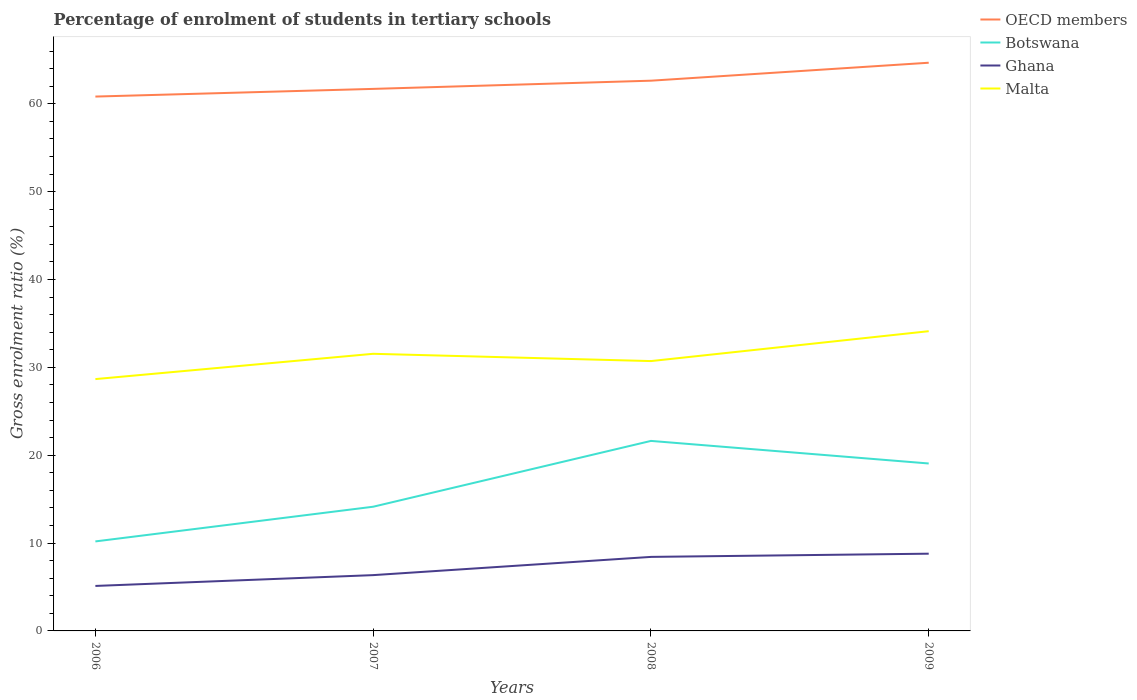Is the number of lines equal to the number of legend labels?
Offer a very short reply. Yes. Across all years, what is the maximum percentage of students enrolled in tertiary schools in Botswana?
Your response must be concise. 10.19. In which year was the percentage of students enrolled in tertiary schools in OECD members maximum?
Provide a succinct answer. 2006. What is the total percentage of students enrolled in tertiary schools in Malta in the graph?
Your answer should be compact. 0.83. What is the difference between the highest and the second highest percentage of students enrolled in tertiary schools in Malta?
Your answer should be compact. 5.45. Is the percentage of students enrolled in tertiary schools in Botswana strictly greater than the percentage of students enrolled in tertiary schools in Ghana over the years?
Keep it short and to the point. No. How many lines are there?
Keep it short and to the point. 4. Are the values on the major ticks of Y-axis written in scientific E-notation?
Your response must be concise. No. Does the graph contain any zero values?
Provide a short and direct response. No. Does the graph contain grids?
Offer a terse response. No. How are the legend labels stacked?
Your answer should be very brief. Vertical. What is the title of the graph?
Your answer should be compact. Percentage of enrolment of students in tertiary schools. Does "Uzbekistan" appear as one of the legend labels in the graph?
Make the answer very short. No. What is the label or title of the X-axis?
Provide a short and direct response. Years. What is the Gross enrolment ratio (%) in OECD members in 2006?
Offer a very short reply. 60.82. What is the Gross enrolment ratio (%) of Botswana in 2006?
Offer a terse response. 10.19. What is the Gross enrolment ratio (%) in Ghana in 2006?
Provide a succinct answer. 5.12. What is the Gross enrolment ratio (%) of Malta in 2006?
Your response must be concise. 28.66. What is the Gross enrolment ratio (%) of OECD members in 2007?
Provide a succinct answer. 61.69. What is the Gross enrolment ratio (%) of Botswana in 2007?
Provide a succinct answer. 14.14. What is the Gross enrolment ratio (%) of Ghana in 2007?
Provide a short and direct response. 6.35. What is the Gross enrolment ratio (%) of Malta in 2007?
Make the answer very short. 31.54. What is the Gross enrolment ratio (%) in OECD members in 2008?
Your response must be concise. 62.62. What is the Gross enrolment ratio (%) of Botswana in 2008?
Provide a succinct answer. 21.63. What is the Gross enrolment ratio (%) in Ghana in 2008?
Offer a very short reply. 8.43. What is the Gross enrolment ratio (%) of Malta in 2008?
Provide a succinct answer. 30.71. What is the Gross enrolment ratio (%) of OECD members in 2009?
Make the answer very short. 64.67. What is the Gross enrolment ratio (%) of Botswana in 2009?
Give a very brief answer. 19.06. What is the Gross enrolment ratio (%) of Ghana in 2009?
Provide a succinct answer. 8.79. What is the Gross enrolment ratio (%) of Malta in 2009?
Provide a succinct answer. 34.11. Across all years, what is the maximum Gross enrolment ratio (%) in OECD members?
Your answer should be compact. 64.67. Across all years, what is the maximum Gross enrolment ratio (%) in Botswana?
Give a very brief answer. 21.63. Across all years, what is the maximum Gross enrolment ratio (%) in Ghana?
Your answer should be compact. 8.79. Across all years, what is the maximum Gross enrolment ratio (%) in Malta?
Your answer should be very brief. 34.11. Across all years, what is the minimum Gross enrolment ratio (%) of OECD members?
Keep it short and to the point. 60.82. Across all years, what is the minimum Gross enrolment ratio (%) in Botswana?
Offer a terse response. 10.19. Across all years, what is the minimum Gross enrolment ratio (%) in Ghana?
Give a very brief answer. 5.12. Across all years, what is the minimum Gross enrolment ratio (%) in Malta?
Ensure brevity in your answer.  28.66. What is the total Gross enrolment ratio (%) in OECD members in the graph?
Provide a short and direct response. 249.81. What is the total Gross enrolment ratio (%) of Botswana in the graph?
Your response must be concise. 65.01. What is the total Gross enrolment ratio (%) of Ghana in the graph?
Provide a short and direct response. 28.69. What is the total Gross enrolment ratio (%) of Malta in the graph?
Your answer should be very brief. 125.03. What is the difference between the Gross enrolment ratio (%) in OECD members in 2006 and that in 2007?
Provide a succinct answer. -0.87. What is the difference between the Gross enrolment ratio (%) in Botswana in 2006 and that in 2007?
Make the answer very short. -3.95. What is the difference between the Gross enrolment ratio (%) in Ghana in 2006 and that in 2007?
Your answer should be very brief. -1.23. What is the difference between the Gross enrolment ratio (%) of Malta in 2006 and that in 2007?
Your answer should be very brief. -2.88. What is the difference between the Gross enrolment ratio (%) of OECD members in 2006 and that in 2008?
Your answer should be compact. -1.81. What is the difference between the Gross enrolment ratio (%) of Botswana in 2006 and that in 2008?
Give a very brief answer. -11.44. What is the difference between the Gross enrolment ratio (%) in Ghana in 2006 and that in 2008?
Make the answer very short. -3.3. What is the difference between the Gross enrolment ratio (%) in Malta in 2006 and that in 2008?
Your answer should be compact. -2.05. What is the difference between the Gross enrolment ratio (%) of OECD members in 2006 and that in 2009?
Give a very brief answer. -3.85. What is the difference between the Gross enrolment ratio (%) of Botswana in 2006 and that in 2009?
Provide a short and direct response. -8.87. What is the difference between the Gross enrolment ratio (%) of Ghana in 2006 and that in 2009?
Your response must be concise. -3.67. What is the difference between the Gross enrolment ratio (%) in Malta in 2006 and that in 2009?
Give a very brief answer. -5.45. What is the difference between the Gross enrolment ratio (%) of OECD members in 2007 and that in 2008?
Provide a succinct answer. -0.93. What is the difference between the Gross enrolment ratio (%) in Botswana in 2007 and that in 2008?
Your answer should be compact. -7.49. What is the difference between the Gross enrolment ratio (%) in Ghana in 2007 and that in 2008?
Your answer should be very brief. -2.07. What is the difference between the Gross enrolment ratio (%) in Malta in 2007 and that in 2008?
Offer a very short reply. 0.83. What is the difference between the Gross enrolment ratio (%) of OECD members in 2007 and that in 2009?
Provide a short and direct response. -2.98. What is the difference between the Gross enrolment ratio (%) of Botswana in 2007 and that in 2009?
Ensure brevity in your answer.  -4.92. What is the difference between the Gross enrolment ratio (%) in Ghana in 2007 and that in 2009?
Ensure brevity in your answer.  -2.44. What is the difference between the Gross enrolment ratio (%) of Malta in 2007 and that in 2009?
Keep it short and to the point. -2.57. What is the difference between the Gross enrolment ratio (%) in OECD members in 2008 and that in 2009?
Your answer should be very brief. -2.04. What is the difference between the Gross enrolment ratio (%) in Botswana in 2008 and that in 2009?
Offer a terse response. 2.57. What is the difference between the Gross enrolment ratio (%) of Ghana in 2008 and that in 2009?
Provide a short and direct response. -0.36. What is the difference between the Gross enrolment ratio (%) of Malta in 2008 and that in 2009?
Ensure brevity in your answer.  -3.4. What is the difference between the Gross enrolment ratio (%) of OECD members in 2006 and the Gross enrolment ratio (%) of Botswana in 2007?
Your response must be concise. 46.68. What is the difference between the Gross enrolment ratio (%) of OECD members in 2006 and the Gross enrolment ratio (%) of Ghana in 2007?
Your answer should be very brief. 54.47. What is the difference between the Gross enrolment ratio (%) of OECD members in 2006 and the Gross enrolment ratio (%) of Malta in 2007?
Your response must be concise. 29.28. What is the difference between the Gross enrolment ratio (%) in Botswana in 2006 and the Gross enrolment ratio (%) in Ghana in 2007?
Keep it short and to the point. 3.84. What is the difference between the Gross enrolment ratio (%) of Botswana in 2006 and the Gross enrolment ratio (%) of Malta in 2007?
Your answer should be very brief. -21.35. What is the difference between the Gross enrolment ratio (%) in Ghana in 2006 and the Gross enrolment ratio (%) in Malta in 2007?
Ensure brevity in your answer.  -26.42. What is the difference between the Gross enrolment ratio (%) of OECD members in 2006 and the Gross enrolment ratio (%) of Botswana in 2008?
Provide a succinct answer. 39.19. What is the difference between the Gross enrolment ratio (%) in OECD members in 2006 and the Gross enrolment ratio (%) in Ghana in 2008?
Your answer should be compact. 52.39. What is the difference between the Gross enrolment ratio (%) of OECD members in 2006 and the Gross enrolment ratio (%) of Malta in 2008?
Give a very brief answer. 30.11. What is the difference between the Gross enrolment ratio (%) in Botswana in 2006 and the Gross enrolment ratio (%) in Ghana in 2008?
Keep it short and to the point. 1.76. What is the difference between the Gross enrolment ratio (%) of Botswana in 2006 and the Gross enrolment ratio (%) of Malta in 2008?
Provide a succinct answer. -20.52. What is the difference between the Gross enrolment ratio (%) of Ghana in 2006 and the Gross enrolment ratio (%) of Malta in 2008?
Ensure brevity in your answer.  -25.59. What is the difference between the Gross enrolment ratio (%) of OECD members in 2006 and the Gross enrolment ratio (%) of Botswana in 2009?
Keep it short and to the point. 41.76. What is the difference between the Gross enrolment ratio (%) in OECD members in 2006 and the Gross enrolment ratio (%) in Ghana in 2009?
Your response must be concise. 52.03. What is the difference between the Gross enrolment ratio (%) in OECD members in 2006 and the Gross enrolment ratio (%) in Malta in 2009?
Give a very brief answer. 26.71. What is the difference between the Gross enrolment ratio (%) in Botswana in 2006 and the Gross enrolment ratio (%) in Ghana in 2009?
Your answer should be very brief. 1.4. What is the difference between the Gross enrolment ratio (%) of Botswana in 2006 and the Gross enrolment ratio (%) of Malta in 2009?
Your answer should be compact. -23.93. What is the difference between the Gross enrolment ratio (%) in Ghana in 2006 and the Gross enrolment ratio (%) in Malta in 2009?
Your answer should be very brief. -28.99. What is the difference between the Gross enrolment ratio (%) in OECD members in 2007 and the Gross enrolment ratio (%) in Botswana in 2008?
Your answer should be compact. 40.07. What is the difference between the Gross enrolment ratio (%) of OECD members in 2007 and the Gross enrolment ratio (%) of Ghana in 2008?
Give a very brief answer. 53.27. What is the difference between the Gross enrolment ratio (%) of OECD members in 2007 and the Gross enrolment ratio (%) of Malta in 2008?
Make the answer very short. 30.98. What is the difference between the Gross enrolment ratio (%) of Botswana in 2007 and the Gross enrolment ratio (%) of Ghana in 2008?
Ensure brevity in your answer.  5.71. What is the difference between the Gross enrolment ratio (%) in Botswana in 2007 and the Gross enrolment ratio (%) in Malta in 2008?
Offer a very short reply. -16.58. What is the difference between the Gross enrolment ratio (%) of Ghana in 2007 and the Gross enrolment ratio (%) of Malta in 2008?
Keep it short and to the point. -24.36. What is the difference between the Gross enrolment ratio (%) of OECD members in 2007 and the Gross enrolment ratio (%) of Botswana in 2009?
Provide a succinct answer. 42.64. What is the difference between the Gross enrolment ratio (%) of OECD members in 2007 and the Gross enrolment ratio (%) of Ghana in 2009?
Your response must be concise. 52.9. What is the difference between the Gross enrolment ratio (%) of OECD members in 2007 and the Gross enrolment ratio (%) of Malta in 2009?
Your answer should be compact. 27.58. What is the difference between the Gross enrolment ratio (%) of Botswana in 2007 and the Gross enrolment ratio (%) of Ghana in 2009?
Give a very brief answer. 5.35. What is the difference between the Gross enrolment ratio (%) of Botswana in 2007 and the Gross enrolment ratio (%) of Malta in 2009?
Offer a terse response. -19.98. What is the difference between the Gross enrolment ratio (%) in Ghana in 2007 and the Gross enrolment ratio (%) in Malta in 2009?
Make the answer very short. -27.76. What is the difference between the Gross enrolment ratio (%) in OECD members in 2008 and the Gross enrolment ratio (%) in Botswana in 2009?
Keep it short and to the point. 43.57. What is the difference between the Gross enrolment ratio (%) in OECD members in 2008 and the Gross enrolment ratio (%) in Ghana in 2009?
Keep it short and to the point. 53.83. What is the difference between the Gross enrolment ratio (%) in OECD members in 2008 and the Gross enrolment ratio (%) in Malta in 2009?
Make the answer very short. 28.51. What is the difference between the Gross enrolment ratio (%) of Botswana in 2008 and the Gross enrolment ratio (%) of Ghana in 2009?
Provide a short and direct response. 12.84. What is the difference between the Gross enrolment ratio (%) of Botswana in 2008 and the Gross enrolment ratio (%) of Malta in 2009?
Make the answer very short. -12.49. What is the difference between the Gross enrolment ratio (%) of Ghana in 2008 and the Gross enrolment ratio (%) of Malta in 2009?
Your answer should be very brief. -25.69. What is the average Gross enrolment ratio (%) in OECD members per year?
Offer a very short reply. 62.45. What is the average Gross enrolment ratio (%) of Botswana per year?
Your response must be concise. 16.25. What is the average Gross enrolment ratio (%) in Ghana per year?
Give a very brief answer. 7.17. What is the average Gross enrolment ratio (%) of Malta per year?
Make the answer very short. 31.26. In the year 2006, what is the difference between the Gross enrolment ratio (%) in OECD members and Gross enrolment ratio (%) in Botswana?
Your answer should be very brief. 50.63. In the year 2006, what is the difference between the Gross enrolment ratio (%) in OECD members and Gross enrolment ratio (%) in Ghana?
Ensure brevity in your answer.  55.7. In the year 2006, what is the difference between the Gross enrolment ratio (%) in OECD members and Gross enrolment ratio (%) in Malta?
Provide a short and direct response. 32.16. In the year 2006, what is the difference between the Gross enrolment ratio (%) in Botswana and Gross enrolment ratio (%) in Ghana?
Your response must be concise. 5.07. In the year 2006, what is the difference between the Gross enrolment ratio (%) in Botswana and Gross enrolment ratio (%) in Malta?
Your answer should be very brief. -18.48. In the year 2006, what is the difference between the Gross enrolment ratio (%) of Ghana and Gross enrolment ratio (%) of Malta?
Your answer should be compact. -23.54. In the year 2007, what is the difference between the Gross enrolment ratio (%) in OECD members and Gross enrolment ratio (%) in Botswana?
Offer a very short reply. 47.56. In the year 2007, what is the difference between the Gross enrolment ratio (%) of OECD members and Gross enrolment ratio (%) of Ghana?
Make the answer very short. 55.34. In the year 2007, what is the difference between the Gross enrolment ratio (%) of OECD members and Gross enrolment ratio (%) of Malta?
Offer a very short reply. 30.15. In the year 2007, what is the difference between the Gross enrolment ratio (%) of Botswana and Gross enrolment ratio (%) of Ghana?
Ensure brevity in your answer.  7.79. In the year 2007, what is the difference between the Gross enrolment ratio (%) of Botswana and Gross enrolment ratio (%) of Malta?
Your response must be concise. -17.41. In the year 2007, what is the difference between the Gross enrolment ratio (%) of Ghana and Gross enrolment ratio (%) of Malta?
Your answer should be compact. -25.19. In the year 2008, what is the difference between the Gross enrolment ratio (%) of OECD members and Gross enrolment ratio (%) of Botswana?
Provide a succinct answer. 41. In the year 2008, what is the difference between the Gross enrolment ratio (%) of OECD members and Gross enrolment ratio (%) of Ghana?
Provide a succinct answer. 54.2. In the year 2008, what is the difference between the Gross enrolment ratio (%) in OECD members and Gross enrolment ratio (%) in Malta?
Offer a very short reply. 31.91. In the year 2008, what is the difference between the Gross enrolment ratio (%) in Botswana and Gross enrolment ratio (%) in Ghana?
Give a very brief answer. 13.2. In the year 2008, what is the difference between the Gross enrolment ratio (%) of Botswana and Gross enrolment ratio (%) of Malta?
Provide a succinct answer. -9.09. In the year 2008, what is the difference between the Gross enrolment ratio (%) in Ghana and Gross enrolment ratio (%) in Malta?
Offer a terse response. -22.29. In the year 2009, what is the difference between the Gross enrolment ratio (%) in OECD members and Gross enrolment ratio (%) in Botswana?
Offer a very short reply. 45.61. In the year 2009, what is the difference between the Gross enrolment ratio (%) of OECD members and Gross enrolment ratio (%) of Ghana?
Your answer should be compact. 55.88. In the year 2009, what is the difference between the Gross enrolment ratio (%) of OECD members and Gross enrolment ratio (%) of Malta?
Ensure brevity in your answer.  30.56. In the year 2009, what is the difference between the Gross enrolment ratio (%) in Botswana and Gross enrolment ratio (%) in Ghana?
Keep it short and to the point. 10.27. In the year 2009, what is the difference between the Gross enrolment ratio (%) in Botswana and Gross enrolment ratio (%) in Malta?
Ensure brevity in your answer.  -15.06. In the year 2009, what is the difference between the Gross enrolment ratio (%) of Ghana and Gross enrolment ratio (%) of Malta?
Offer a terse response. -25.32. What is the ratio of the Gross enrolment ratio (%) in OECD members in 2006 to that in 2007?
Your response must be concise. 0.99. What is the ratio of the Gross enrolment ratio (%) of Botswana in 2006 to that in 2007?
Give a very brief answer. 0.72. What is the ratio of the Gross enrolment ratio (%) of Ghana in 2006 to that in 2007?
Keep it short and to the point. 0.81. What is the ratio of the Gross enrolment ratio (%) of Malta in 2006 to that in 2007?
Keep it short and to the point. 0.91. What is the ratio of the Gross enrolment ratio (%) in OECD members in 2006 to that in 2008?
Your response must be concise. 0.97. What is the ratio of the Gross enrolment ratio (%) of Botswana in 2006 to that in 2008?
Provide a short and direct response. 0.47. What is the ratio of the Gross enrolment ratio (%) in Ghana in 2006 to that in 2008?
Your response must be concise. 0.61. What is the ratio of the Gross enrolment ratio (%) in Malta in 2006 to that in 2008?
Provide a short and direct response. 0.93. What is the ratio of the Gross enrolment ratio (%) in OECD members in 2006 to that in 2009?
Your response must be concise. 0.94. What is the ratio of the Gross enrolment ratio (%) of Botswana in 2006 to that in 2009?
Ensure brevity in your answer.  0.53. What is the ratio of the Gross enrolment ratio (%) in Ghana in 2006 to that in 2009?
Your answer should be very brief. 0.58. What is the ratio of the Gross enrolment ratio (%) of Malta in 2006 to that in 2009?
Provide a succinct answer. 0.84. What is the ratio of the Gross enrolment ratio (%) of OECD members in 2007 to that in 2008?
Give a very brief answer. 0.99. What is the ratio of the Gross enrolment ratio (%) in Botswana in 2007 to that in 2008?
Provide a succinct answer. 0.65. What is the ratio of the Gross enrolment ratio (%) in Ghana in 2007 to that in 2008?
Offer a terse response. 0.75. What is the ratio of the Gross enrolment ratio (%) in OECD members in 2007 to that in 2009?
Provide a succinct answer. 0.95. What is the ratio of the Gross enrolment ratio (%) of Botswana in 2007 to that in 2009?
Keep it short and to the point. 0.74. What is the ratio of the Gross enrolment ratio (%) in Ghana in 2007 to that in 2009?
Your response must be concise. 0.72. What is the ratio of the Gross enrolment ratio (%) of Malta in 2007 to that in 2009?
Offer a terse response. 0.92. What is the ratio of the Gross enrolment ratio (%) of OECD members in 2008 to that in 2009?
Your response must be concise. 0.97. What is the ratio of the Gross enrolment ratio (%) of Botswana in 2008 to that in 2009?
Make the answer very short. 1.13. What is the ratio of the Gross enrolment ratio (%) in Ghana in 2008 to that in 2009?
Ensure brevity in your answer.  0.96. What is the ratio of the Gross enrolment ratio (%) in Malta in 2008 to that in 2009?
Provide a succinct answer. 0.9. What is the difference between the highest and the second highest Gross enrolment ratio (%) of OECD members?
Your answer should be very brief. 2.04. What is the difference between the highest and the second highest Gross enrolment ratio (%) of Botswana?
Provide a short and direct response. 2.57. What is the difference between the highest and the second highest Gross enrolment ratio (%) of Ghana?
Your answer should be very brief. 0.36. What is the difference between the highest and the second highest Gross enrolment ratio (%) of Malta?
Provide a short and direct response. 2.57. What is the difference between the highest and the lowest Gross enrolment ratio (%) in OECD members?
Keep it short and to the point. 3.85. What is the difference between the highest and the lowest Gross enrolment ratio (%) of Botswana?
Offer a very short reply. 11.44. What is the difference between the highest and the lowest Gross enrolment ratio (%) of Ghana?
Your answer should be compact. 3.67. What is the difference between the highest and the lowest Gross enrolment ratio (%) in Malta?
Provide a short and direct response. 5.45. 